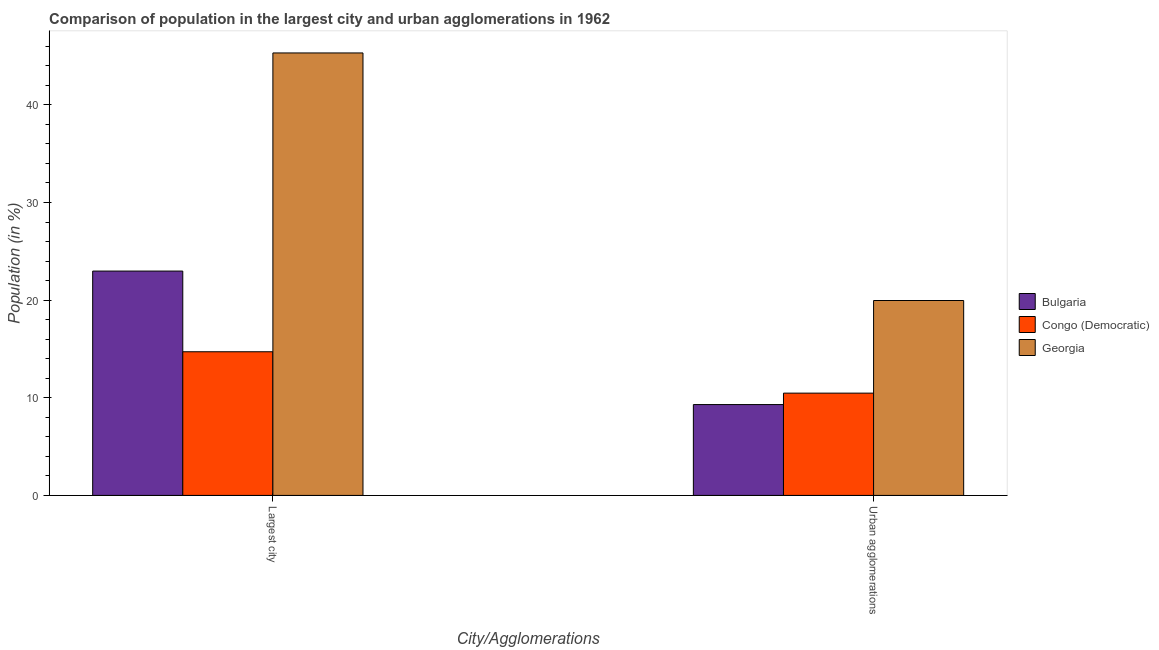How many groups of bars are there?
Your answer should be very brief. 2. How many bars are there on the 2nd tick from the right?
Your answer should be compact. 3. What is the label of the 1st group of bars from the left?
Give a very brief answer. Largest city. What is the population in urban agglomerations in Georgia?
Provide a succinct answer. 19.96. Across all countries, what is the maximum population in urban agglomerations?
Your answer should be very brief. 19.96. Across all countries, what is the minimum population in urban agglomerations?
Give a very brief answer. 9.3. In which country was the population in the largest city maximum?
Offer a very short reply. Georgia. In which country was the population in the largest city minimum?
Ensure brevity in your answer.  Congo (Democratic). What is the total population in the largest city in the graph?
Provide a short and direct response. 83.01. What is the difference between the population in urban agglomerations in Georgia and that in Bulgaria?
Your answer should be very brief. 10.66. What is the difference between the population in urban agglomerations in Georgia and the population in the largest city in Bulgaria?
Provide a succinct answer. -3.01. What is the average population in urban agglomerations per country?
Ensure brevity in your answer.  13.25. What is the difference between the population in the largest city and population in urban agglomerations in Bulgaria?
Your answer should be very brief. 13.67. What is the ratio of the population in the largest city in Bulgaria to that in Congo (Democratic)?
Your answer should be very brief. 1.56. Is the population in the largest city in Congo (Democratic) less than that in Georgia?
Keep it short and to the point. Yes. In how many countries, is the population in urban agglomerations greater than the average population in urban agglomerations taken over all countries?
Provide a short and direct response. 1. What does the 2nd bar from the left in Urban agglomerations represents?
Ensure brevity in your answer.  Congo (Democratic). What does the 1st bar from the right in Largest city represents?
Offer a terse response. Georgia. How many bars are there?
Offer a very short reply. 6. How many countries are there in the graph?
Your response must be concise. 3. What is the difference between two consecutive major ticks on the Y-axis?
Provide a succinct answer. 10. Are the values on the major ticks of Y-axis written in scientific E-notation?
Ensure brevity in your answer.  No. Does the graph contain any zero values?
Provide a short and direct response. No. Does the graph contain grids?
Your answer should be very brief. No. Where does the legend appear in the graph?
Ensure brevity in your answer.  Center right. How are the legend labels stacked?
Your answer should be very brief. Vertical. What is the title of the graph?
Make the answer very short. Comparison of population in the largest city and urban agglomerations in 1962. What is the label or title of the X-axis?
Offer a terse response. City/Agglomerations. What is the Population (in %) in Bulgaria in Largest city?
Your answer should be very brief. 22.98. What is the Population (in %) of Congo (Democratic) in Largest city?
Offer a very short reply. 14.71. What is the Population (in %) in Georgia in Largest city?
Provide a short and direct response. 45.32. What is the Population (in %) of Bulgaria in Urban agglomerations?
Your response must be concise. 9.3. What is the Population (in %) of Congo (Democratic) in Urban agglomerations?
Your answer should be compact. 10.48. What is the Population (in %) in Georgia in Urban agglomerations?
Offer a very short reply. 19.96. Across all City/Agglomerations, what is the maximum Population (in %) in Bulgaria?
Provide a succinct answer. 22.98. Across all City/Agglomerations, what is the maximum Population (in %) of Congo (Democratic)?
Your answer should be compact. 14.71. Across all City/Agglomerations, what is the maximum Population (in %) of Georgia?
Provide a short and direct response. 45.32. Across all City/Agglomerations, what is the minimum Population (in %) of Bulgaria?
Ensure brevity in your answer.  9.3. Across all City/Agglomerations, what is the minimum Population (in %) in Congo (Democratic)?
Your response must be concise. 10.48. Across all City/Agglomerations, what is the minimum Population (in %) in Georgia?
Your answer should be very brief. 19.96. What is the total Population (in %) of Bulgaria in the graph?
Make the answer very short. 32.28. What is the total Population (in %) in Congo (Democratic) in the graph?
Give a very brief answer. 25.19. What is the total Population (in %) in Georgia in the graph?
Make the answer very short. 65.28. What is the difference between the Population (in %) in Bulgaria in Largest city and that in Urban agglomerations?
Ensure brevity in your answer.  13.67. What is the difference between the Population (in %) of Congo (Democratic) in Largest city and that in Urban agglomerations?
Your answer should be very brief. 4.24. What is the difference between the Population (in %) in Georgia in Largest city and that in Urban agglomerations?
Provide a short and direct response. 25.35. What is the difference between the Population (in %) in Bulgaria in Largest city and the Population (in %) in Congo (Democratic) in Urban agglomerations?
Provide a short and direct response. 12.5. What is the difference between the Population (in %) of Bulgaria in Largest city and the Population (in %) of Georgia in Urban agglomerations?
Provide a succinct answer. 3.01. What is the difference between the Population (in %) in Congo (Democratic) in Largest city and the Population (in %) in Georgia in Urban agglomerations?
Provide a succinct answer. -5.25. What is the average Population (in %) in Bulgaria per City/Agglomerations?
Your answer should be compact. 16.14. What is the average Population (in %) of Congo (Democratic) per City/Agglomerations?
Your response must be concise. 12.6. What is the average Population (in %) of Georgia per City/Agglomerations?
Your answer should be compact. 32.64. What is the difference between the Population (in %) of Bulgaria and Population (in %) of Congo (Democratic) in Largest city?
Provide a short and direct response. 8.26. What is the difference between the Population (in %) in Bulgaria and Population (in %) in Georgia in Largest city?
Offer a very short reply. -22.34. What is the difference between the Population (in %) of Congo (Democratic) and Population (in %) of Georgia in Largest city?
Ensure brevity in your answer.  -30.6. What is the difference between the Population (in %) of Bulgaria and Population (in %) of Congo (Democratic) in Urban agglomerations?
Ensure brevity in your answer.  -1.17. What is the difference between the Population (in %) of Bulgaria and Population (in %) of Georgia in Urban agglomerations?
Your answer should be very brief. -10.66. What is the difference between the Population (in %) of Congo (Democratic) and Population (in %) of Georgia in Urban agglomerations?
Your answer should be compact. -9.49. What is the ratio of the Population (in %) in Bulgaria in Largest city to that in Urban agglomerations?
Make the answer very short. 2.47. What is the ratio of the Population (in %) in Congo (Democratic) in Largest city to that in Urban agglomerations?
Offer a terse response. 1.4. What is the ratio of the Population (in %) of Georgia in Largest city to that in Urban agglomerations?
Provide a short and direct response. 2.27. What is the difference between the highest and the second highest Population (in %) in Bulgaria?
Provide a succinct answer. 13.67. What is the difference between the highest and the second highest Population (in %) of Congo (Democratic)?
Provide a short and direct response. 4.24. What is the difference between the highest and the second highest Population (in %) of Georgia?
Provide a short and direct response. 25.35. What is the difference between the highest and the lowest Population (in %) in Bulgaria?
Provide a succinct answer. 13.67. What is the difference between the highest and the lowest Population (in %) of Congo (Democratic)?
Provide a succinct answer. 4.24. What is the difference between the highest and the lowest Population (in %) in Georgia?
Your answer should be very brief. 25.35. 